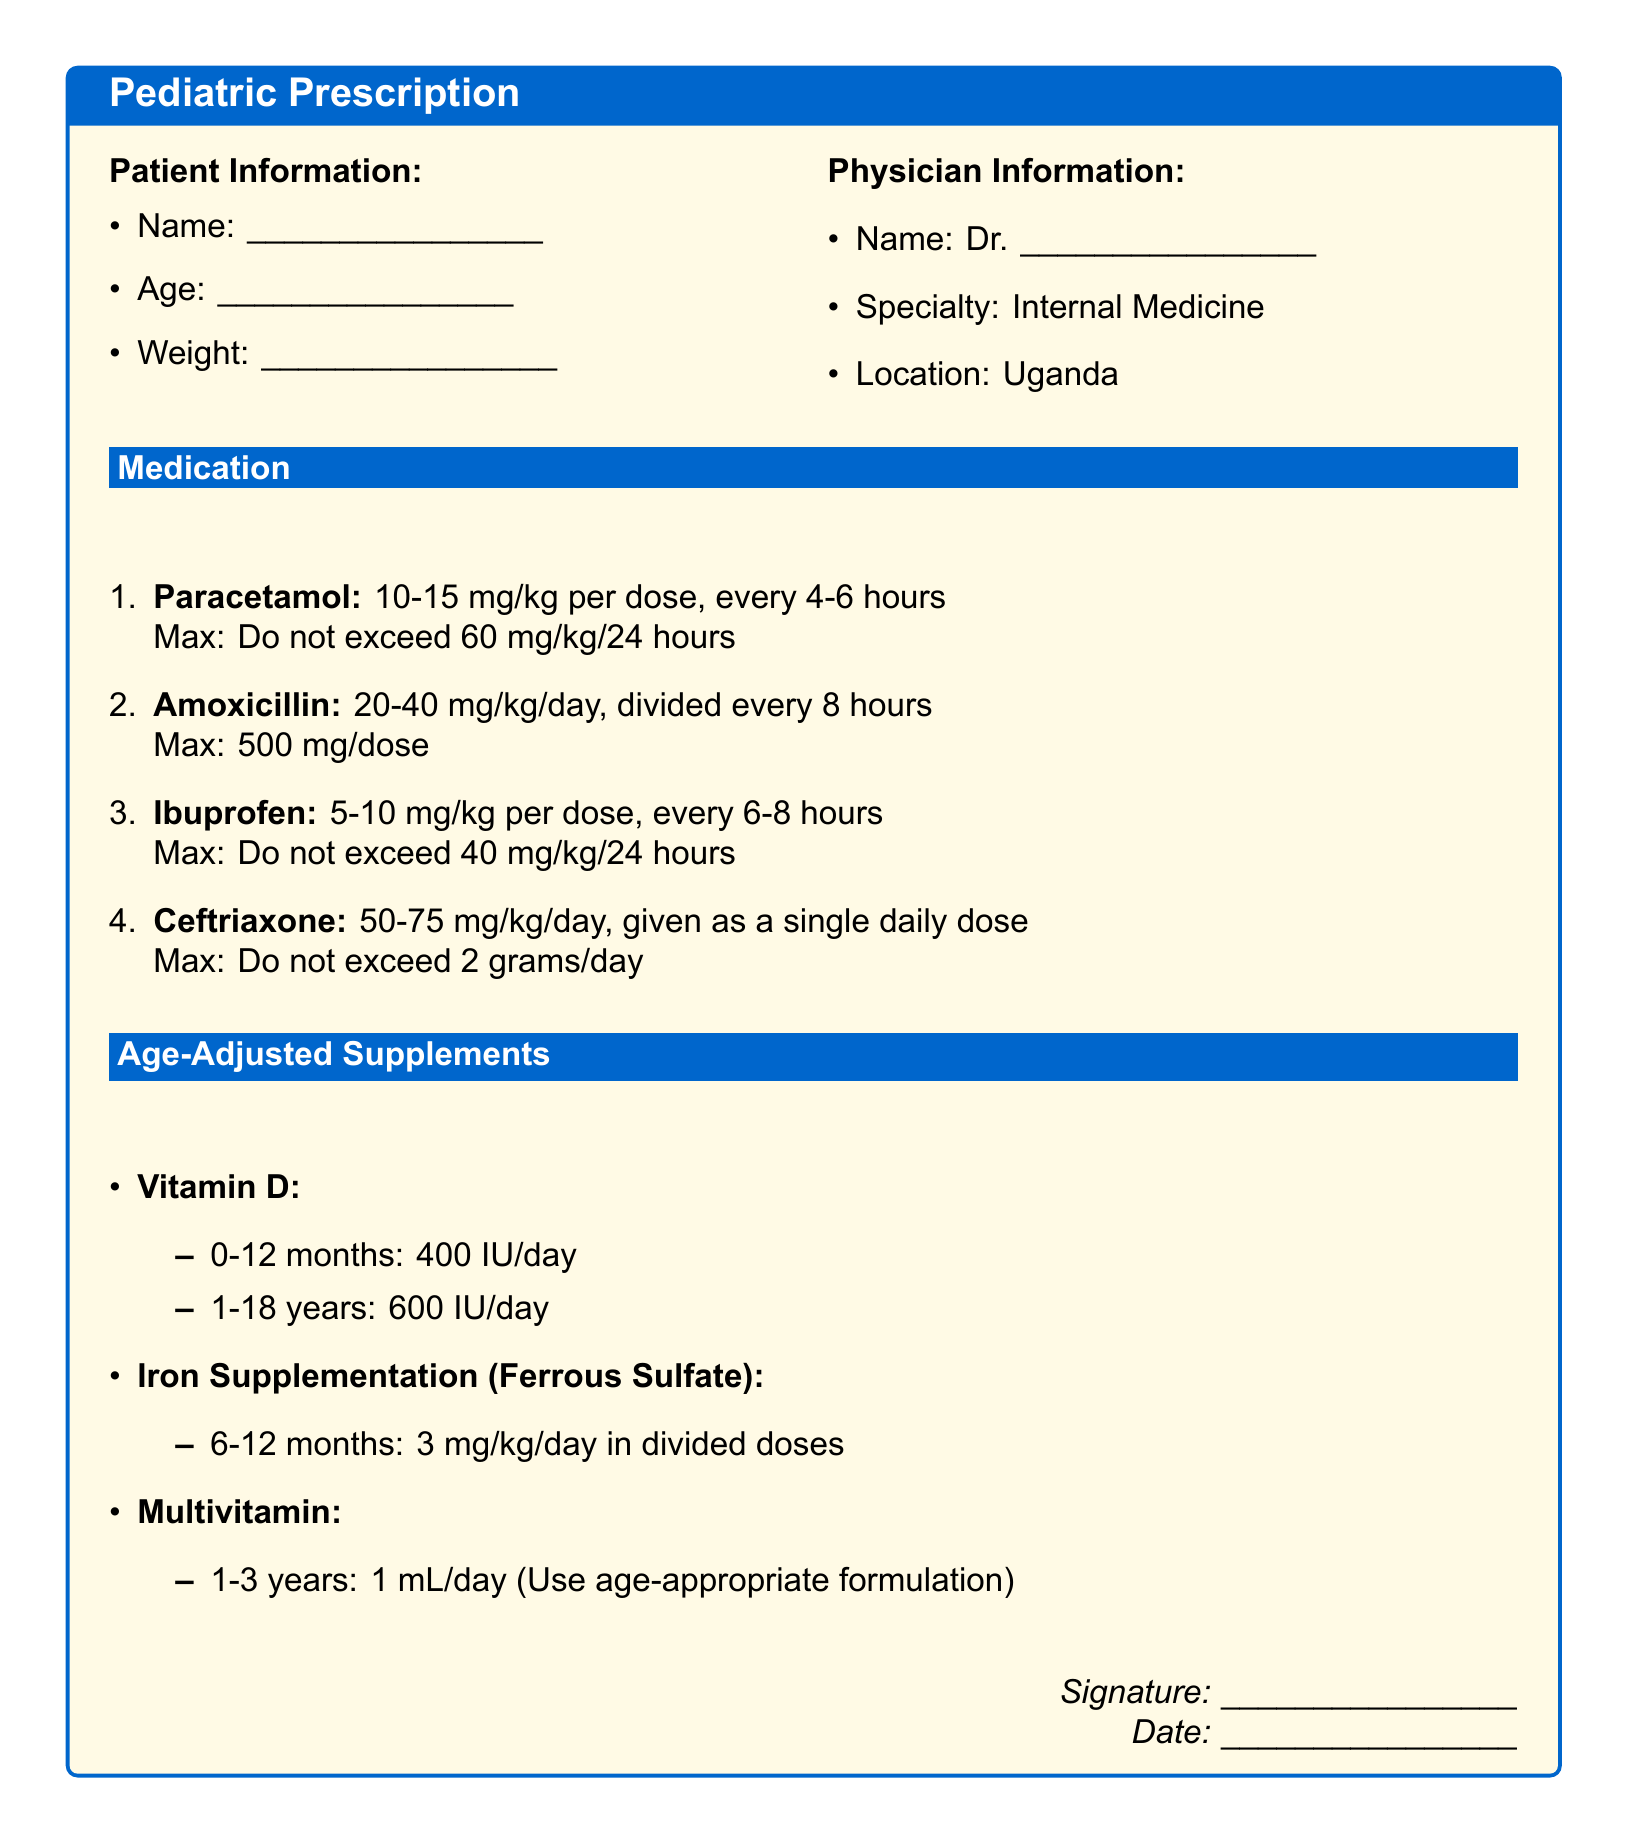What is the prescribed dosage of Paracetamol? Paracetamol is prescribed at a dosage of 10-15 mg/kg per dose.
Answer: 10-15 mg/kg What is the maximum dosage of Amoxicillin per dose? The document states that the maximum dosage of Amoxicillin per dose is 500 mg.
Answer: 500 mg What is the daily dosage of Vitamin D for children aged 1-18 years? For children aged 1-18 years, the daily dosage of Vitamin D is 600 IU.
Answer: 600 IU What weight range does the Iron Supplementation dosage apply to? Iron Supplementation is specified for children aged 6-12 months, not by weight but by age.
Answer: 6-12 months How often should Ibuprofen be administered? Ibuprofen should be administered every 6-8 hours.
Answer: every 6-8 hours What is the maximum daily dosage of Ceftriaxone? The maximum daily dosage of Ceftriaxone is stated as not exceeding 2 grams.
Answer: 2 grams What is the prescribed amount of Multivitamin for children aged 1-3 years? Children aged 1-3 years are prescribed 1 mL/day of Multivitamin.
Answer: 1 mL/day Who is the physician mentioned in the document? The physician’s name is indicated by Dr. followed by a blank line for input, making it customizable.
Answer: Dr. __________ What is the signature section labeled as? The signature section is labeled as “Signature.”
Answer: Signature 